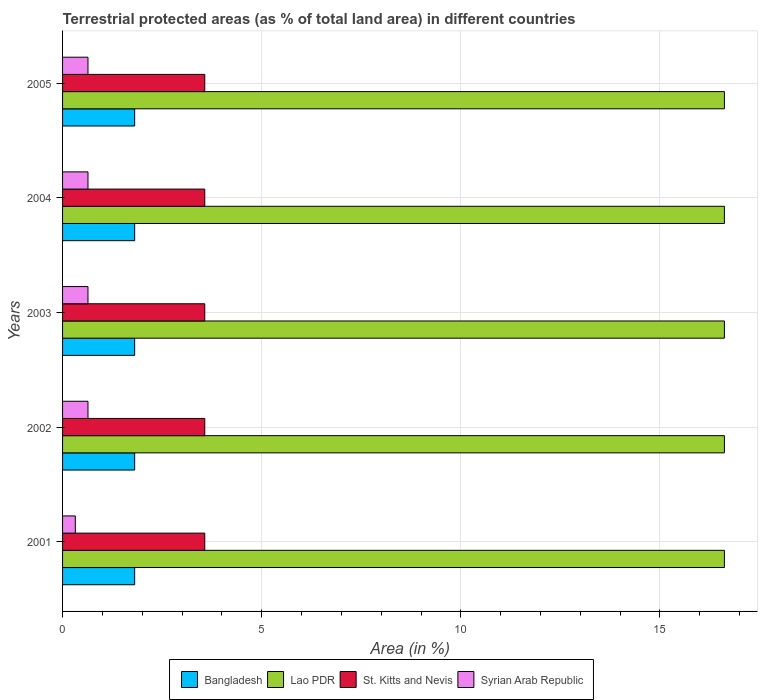How many bars are there on the 1st tick from the top?
Offer a very short reply. 4. How many bars are there on the 5th tick from the bottom?
Ensure brevity in your answer.  4. In how many cases, is the number of bars for a given year not equal to the number of legend labels?
Your answer should be very brief. 0. What is the percentage of terrestrial protected land in Syrian Arab Republic in 2003?
Offer a terse response. 0.64. Across all years, what is the maximum percentage of terrestrial protected land in St. Kitts and Nevis?
Your answer should be compact. 3.57. Across all years, what is the minimum percentage of terrestrial protected land in Syrian Arab Republic?
Keep it short and to the point. 0.32. In which year was the percentage of terrestrial protected land in St. Kitts and Nevis maximum?
Offer a terse response. 2001. In which year was the percentage of terrestrial protected land in Bangladesh minimum?
Your response must be concise. 2001. What is the total percentage of terrestrial protected land in Lao PDR in the graph?
Your answer should be very brief. 83.09. What is the difference between the percentage of terrestrial protected land in Lao PDR in 2004 and the percentage of terrestrial protected land in Syrian Arab Republic in 2001?
Offer a terse response. 16.3. What is the average percentage of terrestrial protected land in Lao PDR per year?
Provide a short and direct response. 16.62. In the year 2004, what is the difference between the percentage of terrestrial protected land in Syrian Arab Republic and percentage of terrestrial protected land in St. Kitts and Nevis?
Keep it short and to the point. -2.93. What is the ratio of the percentage of terrestrial protected land in Lao PDR in 2003 to that in 2005?
Your response must be concise. 1. Is the difference between the percentage of terrestrial protected land in Syrian Arab Republic in 2001 and 2003 greater than the difference between the percentage of terrestrial protected land in St. Kitts and Nevis in 2001 and 2003?
Your answer should be very brief. No. In how many years, is the percentage of terrestrial protected land in Syrian Arab Republic greater than the average percentage of terrestrial protected land in Syrian Arab Republic taken over all years?
Keep it short and to the point. 4. Is the sum of the percentage of terrestrial protected land in Lao PDR in 2001 and 2003 greater than the maximum percentage of terrestrial protected land in Bangladesh across all years?
Provide a succinct answer. Yes. Is it the case that in every year, the sum of the percentage of terrestrial protected land in Bangladesh and percentage of terrestrial protected land in St. Kitts and Nevis is greater than the sum of percentage of terrestrial protected land in Lao PDR and percentage of terrestrial protected land in Syrian Arab Republic?
Provide a succinct answer. No. What does the 2nd bar from the top in 2002 represents?
Give a very brief answer. St. Kitts and Nevis. What does the 3rd bar from the bottom in 2003 represents?
Your answer should be very brief. St. Kitts and Nevis. Is it the case that in every year, the sum of the percentage of terrestrial protected land in Syrian Arab Republic and percentage of terrestrial protected land in Bangladesh is greater than the percentage of terrestrial protected land in St. Kitts and Nevis?
Your response must be concise. No. Are the values on the major ticks of X-axis written in scientific E-notation?
Provide a succinct answer. No. Does the graph contain grids?
Your answer should be very brief. Yes. Where does the legend appear in the graph?
Provide a succinct answer. Bottom center. How many legend labels are there?
Your response must be concise. 4. How are the legend labels stacked?
Provide a short and direct response. Horizontal. What is the title of the graph?
Your answer should be very brief. Terrestrial protected areas (as % of total land area) in different countries. Does "East Asia (all income levels)" appear as one of the legend labels in the graph?
Keep it short and to the point. No. What is the label or title of the X-axis?
Ensure brevity in your answer.  Area (in %). What is the Area (in %) of Bangladesh in 2001?
Provide a succinct answer. 1.81. What is the Area (in %) of Lao PDR in 2001?
Your response must be concise. 16.62. What is the Area (in %) in St. Kitts and Nevis in 2001?
Keep it short and to the point. 3.57. What is the Area (in %) in Syrian Arab Republic in 2001?
Offer a very short reply. 0.32. What is the Area (in %) of Bangladesh in 2002?
Your answer should be compact. 1.81. What is the Area (in %) of Lao PDR in 2002?
Offer a terse response. 16.62. What is the Area (in %) in St. Kitts and Nevis in 2002?
Your answer should be very brief. 3.57. What is the Area (in %) in Syrian Arab Republic in 2002?
Give a very brief answer. 0.64. What is the Area (in %) of Bangladesh in 2003?
Give a very brief answer. 1.81. What is the Area (in %) in Lao PDR in 2003?
Give a very brief answer. 16.62. What is the Area (in %) of St. Kitts and Nevis in 2003?
Your answer should be very brief. 3.57. What is the Area (in %) in Syrian Arab Republic in 2003?
Make the answer very short. 0.64. What is the Area (in %) in Bangladesh in 2004?
Provide a succinct answer. 1.81. What is the Area (in %) of Lao PDR in 2004?
Provide a succinct answer. 16.62. What is the Area (in %) of St. Kitts and Nevis in 2004?
Provide a succinct answer. 3.57. What is the Area (in %) in Syrian Arab Republic in 2004?
Your answer should be compact. 0.64. What is the Area (in %) in Bangladesh in 2005?
Give a very brief answer. 1.81. What is the Area (in %) in Lao PDR in 2005?
Your response must be concise. 16.62. What is the Area (in %) in St. Kitts and Nevis in 2005?
Provide a succinct answer. 3.57. What is the Area (in %) of Syrian Arab Republic in 2005?
Offer a terse response. 0.64. Across all years, what is the maximum Area (in %) of Bangladesh?
Your answer should be very brief. 1.81. Across all years, what is the maximum Area (in %) in Lao PDR?
Provide a short and direct response. 16.62. Across all years, what is the maximum Area (in %) in St. Kitts and Nevis?
Provide a short and direct response. 3.57. Across all years, what is the maximum Area (in %) of Syrian Arab Republic?
Your answer should be compact. 0.64. Across all years, what is the minimum Area (in %) of Bangladesh?
Keep it short and to the point. 1.81. Across all years, what is the minimum Area (in %) of Lao PDR?
Offer a terse response. 16.62. Across all years, what is the minimum Area (in %) of St. Kitts and Nevis?
Provide a short and direct response. 3.57. Across all years, what is the minimum Area (in %) of Syrian Arab Republic?
Give a very brief answer. 0.32. What is the total Area (in %) of Bangladesh in the graph?
Make the answer very short. 9.05. What is the total Area (in %) of Lao PDR in the graph?
Your response must be concise. 83.09. What is the total Area (in %) of St. Kitts and Nevis in the graph?
Make the answer very short. 17.85. What is the total Area (in %) in Syrian Arab Republic in the graph?
Offer a terse response. 2.87. What is the difference between the Area (in %) in Bangladesh in 2001 and that in 2002?
Give a very brief answer. 0. What is the difference between the Area (in %) of Lao PDR in 2001 and that in 2002?
Your answer should be compact. 0. What is the difference between the Area (in %) in Syrian Arab Republic in 2001 and that in 2002?
Make the answer very short. -0.32. What is the difference between the Area (in %) of Lao PDR in 2001 and that in 2003?
Provide a succinct answer. 0. What is the difference between the Area (in %) in St. Kitts and Nevis in 2001 and that in 2003?
Your response must be concise. 0. What is the difference between the Area (in %) in Syrian Arab Republic in 2001 and that in 2003?
Provide a short and direct response. -0.32. What is the difference between the Area (in %) in Lao PDR in 2001 and that in 2004?
Give a very brief answer. 0. What is the difference between the Area (in %) of St. Kitts and Nevis in 2001 and that in 2004?
Ensure brevity in your answer.  0. What is the difference between the Area (in %) of Syrian Arab Republic in 2001 and that in 2004?
Provide a short and direct response. -0.32. What is the difference between the Area (in %) of Lao PDR in 2001 and that in 2005?
Offer a terse response. 0. What is the difference between the Area (in %) in St. Kitts and Nevis in 2001 and that in 2005?
Provide a short and direct response. 0. What is the difference between the Area (in %) in Syrian Arab Republic in 2001 and that in 2005?
Your answer should be very brief. -0.32. What is the difference between the Area (in %) of Lao PDR in 2002 and that in 2003?
Keep it short and to the point. 0. What is the difference between the Area (in %) of Syrian Arab Republic in 2002 and that in 2003?
Your answer should be very brief. 0. What is the difference between the Area (in %) of Lao PDR in 2002 and that in 2004?
Offer a terse response. 0. What is the difference between the Area (in %) in St. Kitts and Nevis in 2002 and that in 2004?
Your answer should be very brief. 0. What is the difference between the Area (in %) in Syrian Arab Republic in 2002 and that in 2004?
Give a very brief answer. 0. What is the difference between the Area (in %) of Bangladesh in 2002 and that in 2005?
Make the answer very short. 0. What is the difference between the Area (in %) of St. Kitts and Nevis in 2002 and that in 2005?
Your answer should be compact. 0. What is the difference between the Area (in %) of Bangladesh in 2003 and that in 2004?
Ensure brevity in your answer.  0. What is the difference between the Area (in %) in Lao PDR in 2003 and that in 2004?
Your answer should be compact. 0. What is the difference between the Area (in %) in St. Kitts and Nevis in 2003 and that in 2004?
Your response must be concise. 0. What is the difference between the Area (in %) of St. Kitts and Nevis in 2003 and that in 2005?
Your answer should be compact. 0. What is the difference between the Area (in %) in St. Kitts and Nevis in 2004 and that in 2005?
Ensure brevity in your answer.  0. What is the difference between the Area (in %) in Syrian Arab Republic in 2004 and that in 2005?
Provide a short and direct response. 0. What is the difference between the Area (in %) in Bangladesh in 2001 and the Area (in %) in Lao PDR in 2002?
Make the answer very short. -14.81. What is the difference between the Area (in %) of Bangladesh in 2001 and the Area (in %) of St. Kitts and Nevis in 2002?
Keep it short and to the point. -1.76. What is the difference between the Area (in %) of Bangladesh in 2001 and the Area (in %) of Syrian Arab Republic in 2002?
Provide a succinct answer. 1.17. What is the difference between the Area (in %) in Lao PDR in 2001 and the Area (in %) in St. Kitts and Nevis in 2002?
Ensure brevity in your answer.  13.05. What is the difference between the Area (in %) of Lao PDR in 2001 and the Area (in %) of Syrian Arab Republic in 2002?
Your answer should be compact. 15.98. What is the difference between the Area (in %) of St. Kitts and Nevis in 2001 and the Area (in %) of Syrian Arab Republic in 2002?
Give a very brief answer. 2.93. What is the difference between the Area (in %) of Bangladesh in 2001 and the Area (in %) of Lao PDR in 2003?
Ensure brevity in your answer.  -14.81. What is the difference between the Area (in %) of Bangladesh in 2001 and the Area (in %) of St. Kitts and Nevis in 2003?
Provide a succinct answer. -1.76. What is the difference between the Area (in %) of Bangladesh in 2001 and the Area (in %) of Syrian Arab Republic in 2003?
Provide a succinct answer. 1.17. What is the difference between the Area (in %) in Lao PDR in 2001 and the Area (in %) in St. Kitts and Nevis in 2003?
Give a very brief answer. 13.05. What is the difference between the Area (in %) in Lao PDR in 2001 and the Area (in %) in Syrian Arab Republic in 2003?
Your answer should be very brief. 15.98. What is the difference between the Area (in %) in St. Kitts and Nevis in 2001 and the Area (in %) in Syrian Arab Republic in 2003?
Make the answer very short. 2.93. What is the difference between the Area (in %) in Bangladesh in 2001 and the Area (in %) in Lao PDR in 2004?
Provide a succinct answer. -14.81. What is the difference between the Area (in %) of Bangladesh in 2001 and the Area (in %) of St. Kitts and Nevis in 2004?
Give a very brief answer. -1.76. What is the difference between the Area (in %) of Bangladesh in 2001 and the Area (in %) of Syrian Arab Republic in 2004?
Keep it short and to the point. 1.17. What is the difference between the Area (in %) in Lao PDR in 2001 and the Area (in %) in St. Kitts and Nevis in 2004?
Offer a terse response. 13.05. What is the difference between the Area (in %) of Lao PDR in 2001 and the Area (in %) of Syrian Arab Republic in 2004?
Provide a succinct answer. 15.98. What is the difference between the Area (in %) of St. Kitts and Nevis in 2001 and the Area (in %) of Syrian Arab Republic in 2004?
Offer a very short reply. 2.93. What is the difference between the Area (in %) of Bangladesh in 2001 and the Area (in %) of Lao PDR in 2005?
Provide a succinct answer. -14.81. What is the difference between the Area (in %) of Bangladesh in 2001 and the Area (in %) of St. Kitts and Nevis in 2005?
Your response must be concise. -1.76. What is the difference between the Area (in %) in Bangladesh in 2001 and the Area (in %) in Syrian Arab Republic in 2005?
Ensure brevity in your answer.  1.17. What is the difference between the Area (in %) in Lao PDR in 2001 and the Area (in %) in St. Kitts and Nevis in 2005?
Your answer should be compact. 13.05. What is the difference between the Area (in %) of Lao PDR in 2001 and the Area (in %) of Syrian Arab Republic in 2005?
Provide a succinct answer. 15.98. What is the difference between the Area (in %) of St. Kitts and Nevis in 2001 and the Area (in %) of Syrian Arab Republic in 2005?
Make the answer very short. 2.93. What is the difference between the Area (in %) in Bangladesh in 2002 and the Area (in %) in Lao PDR in 2003?
Provide a short and direct response. -14.81. What is the difference between the Area (in %) in Bangladesh in 2002 and the Area (in %) in St. Kitts and Nevis in 2003?
Offer a terse response. -1.76. What is the difference between the Area (in %) of Bangladesh in 2002 and the Area (in %) of Syrian Arab Republic in 2003?
Provide a short and direct response. 1.17. What is the difference between the Area (in %) of Lao PDR in 2002 and the Area (in %) of St. Kitts and Nevis in 2003?
Provide a succinct answer. 13.05. What is the difference between the Area (in %) in Lao PDR in 2002 and the Area (in %) in Syrian Arab Republic in 2003?
Ensure brevity in your answer.  15.98. What is the difference between the Area (in %) of St. Kitts and Nevis in 2002 and the Area (in %) of Syrian Arab Republic in 2003?
Your answer should be compact. 2.93. What is the difference between the Area (in %) in Bangladesh in 2002 and the Area (in %) in Lao PDR in 2004?
Ensure brevity in your answer.  -14.81. What is the difference between the Area (in %) in Bangladesh in 2002 and the Area (in %) in St. Kitts and Nevis in 2004?
Provide a short and direct response. -1.76. What is the difference between the Area (in %) of Bangladesh in 2002 and the Area (in %) of Syrian Arab Republic in 2004?
Provide a succinct answer. 1.17. What is the difference between the Area (in %) in Lao PDR in 2002 and the Area (in %) in St. Kitts and Nevis in 2004?
Your answer should be compact. 13.05. What is the difference between the Area (in %) in Lao PDR in 2002 and the Area (in %) in Syrian Arab Republic in 2004?
Offer a very short reply. 15.98. What is the difference between the Area (in %) in St. Kitts and Nevis in 2002 and the Area (in %) in Syrian Arab Republic in 2004?
Make the answer very short. 2.93. What is the difference between the Area (in %) of Bangladesh in 2002 and the Area (in %) of Lao PDR in 2005?
Your answer should be very brief. -14.81. What is the difference between the Area (in %) in Bangladesh in 2002 and the Area (in %) in St. Kitts and Nevis in 2005?
Your answer should be very brief. -1.76. What is the difference between the Area (in %) of Bangladesh in 2002 and the Area (in %) of Syrian Arab Republic in 2005?
Give a very brief answer. 1.17. What is the difference between the Area (in %) of Lao PDR in 2002 and the Area (in %) of St. Kitts and Nevis in 2005?
Make the answer very short. 13.05. What is the difference between the Area (in %) of Lao PDR in 2002 and the Area (in %) of Syrian Arab Republic in 2005?
Offer a very short reply. 15.98. What is the difference between the Area (in %) in St. Kitts and Nevis in 2002 and the Area (in %) in Syrian Arab Republic in 2005?
Your response must be concise. 2.93. What is the difference between the Area (in %) in Bangladesh in 2003 and the Area (in %) in Lao PDR in 2004?
Keep it short and to the point. -14.81. What is the difference between the Area (in %) of Bangladesh in 2003 and the Area (in %) of St. Kitts and Nevis in 2004?
Ensure brevity in your answer.  -1.76. What is the difference between the Area (in %) of Bangladesh in 2003 and the Area (in %) of Syrian Arab Republic in 2004?
Your response must be concise. 1.17. What is the difference between the Area (in %) of Lao PDR in 2003 and the Area (in %) of St. Kitts and Nevis in 2004?
Your answer should be compact. 13.05. What is the difference between the Area (in %) of Lao PDR in 2003 and the Area (in %) of Syrian Arab Republic in 2004?
Your answer should be compact. 15.98. What is the difference between the Area (in %) in St. Kitts and Nevis in 2003 and the Area (in %) in Syrian Arab Republic in 2004?
Give a very brief answer. 2.93. What is the difference between the Area (in %) of Bangladesh in 2003 and the Area (in %) of Lao PDR in 2005?
Your answer should be very brief. -14.81. What is the difference between the Area (in %) of Bangladesh in 2003 and the Area (in %) of St. Kitts and Nevis in 2005?
Make the answer very short. -1.76. What is the difference between the Area (in %) in Bangladesh in 2003 and the Area (in %) in Syrian Arab Republic in 2005?
Your response must be concise. 1.17. What is the difference between the Area (in %) in Lao PDR in 2003 and the Area (in %) in St. Kitts and Nevis in 2005?
Provide a succinct answer. 13.05. What is the difference between the Area (in %) of Lao PDR in 2003 and the Area (in %) of Syrian Arab Republic in 2005?
Ensure brevity in your answer.  15.98. What is the difference between the Area (in %) in St. Kitts and Nevis in 2003 and the Area (in %) in Syrian Arab Republic in 2005?
Keep it short and to the point. 2.93. What is the difference between the Area (in %) of Bangladesh in 2004 and the Area (in %) of Lao PDR in 2005?
Your answer should be very brief. -14.81. What is the difference between the Area (in %) of Bangladesh in 2004 and the Area (in %) of St. Kitts and Nevis in 2005?
Make the answer very short. -1.76. What is the difference between the Area (in %) of Bangladesh in 2004 and the Area (in %) of Syrian Arab Republic in 2005?
Provide a short and direct response. 1.17. What is the difference between the Area (in %) in Lao PDR in 2004 and the Area (in %) in St. Kitts and Nevis in 2005?
Your answer should be compact. 13.05. What is the difference between the Area (in %) in Lao PDR in 2004 and the Area (in %) in Syrian Arab Republic in 2005?
Provide a short and direct response. 15.98. What is the difference between the Area (in %) in St. Kitts and Nevis in 2004 and the Area (in %) in Syrian Arab Republic in 2005?
Offer a terse response. 2.93. What is the average Area (in %) in Bangladesh per year?
Keep it short and to the point. 1.81. What is the average Area (in %) in Lao PDR per year?
Provide a short and direct response. 16.62. What is the average Area (in %) in St. Kitts and Nevis per year?
Your answer should be very brief. 3.57. What is the average Area (in %) in Syrian Arab Republic per year?
Your response must be concise. 0.57. In the year 2001, what is the difference between the Area (in %) in Bangladesh and Area (in %) in Lao PDR?
Ensure brevity in your answer.  -14.81. In the year 2001, what is the difference between the Area (in %) in Bangladesh and Area (in %) in St. Kitts and Nevis?
Your response must be concise. -1.76. In the year 2001, what is the difference between the Area (in %) of Bangladesh and Area (in %) of Syrian Arab Republic?
Your answer should be very brief. 1.49. In the year 2001, what is the difference between the Area (in %) of Lao PDR and Area (in %) of St. Kitts and Nevis?
Make the answer very short. 13.05. In the year 2001, what is the difference between the Area (in %) of Lao PDR and Area (in %) of Syrian Arab Republic?
Provide a succinct answer. 16.3. In the year 2001, what is the difference between the Area (in %) in St. Kitts and Nevis and Area (in %) in Syrian Arab Republic?
Your answer should be compact. 3.25. In the year 2002, what is the difference between the Area (in %) of Bangladesh and Area (in %) of Lao PDR?
Provide a short and direct response. -14.81. In the year 2002, what is the difference between the Area (in %) of Bangladesh and Area (in %) of St. Kitts and Nevis?
Your response must be concise. -1.76. In the year 2002, what is the difference between the Area (in %) in Bangladesh and Area (in %) in Syrian Arab Republic?
Ensure brevity in your answer.  1.17. In the year 2002, what is the difference between the Area (in %) of Lao PDR and Area (in %) of St. Kitts and Nevis?
Your response must be concise. 13.05. In the year 2002, what is the difference between the Area (in %) of Lao PDR and Area (in %) of Syrian Arab Republic?
Make the answer very short. 15.98. In the year 2002, what is the difference between the Area (in %) in St. Kitts and Nevis and Area (in %) in Syrian Arab Republic?
Give a very brief answer. 2.93. In the year 2003, what is the difference between the Area (in %) in Bangladesh and Area (in %) in Lao PDR?
Make the answer very short. -14.81. In the year 2003, what is the difference between the Area (in %) in Bangladesh and Area (in %) in St. Kitts and Nevis?
Make the answer very short. -1.76. In the year 2003, what is the difference between the Area (in %) in Bangladesh and Area (in %) in Syrian Arab Republic?
Your answer should be very brief. 1.17. In the year 2003, what is the difference between the Area (in %) of Lao PDR and Area (in %) of St. Kitts and Nevis?
Provide a short and direct response. 13.05. In the year 2003, what is the difference between the Area (in %) in Lao PDR and Area (in %) in Syrian Arab Republic?
Ensure brevity in your answer.  15.98. In the year 2003, what is the difference between the Area (in %) in St. Kitts and Nevis and Area (in %) in Syrian Arab Republic?
Your response must be concise. 2.93. In the year 2004, what is the difference between the Area (in %) of Bangladesh and Area (in %) of Lao PDR?
Provide a succinct answer. -14.81. In the year 2004, what is the difference between the Area (in %) of Bangladesh and Area (in %) of St. Kitts and Nevis?
Offer a terse response. -1.76. In the year 2004, what is the difference between the Area (in %) of Bangladesh and Area (in %) of Syrian Arab Republic?
Your answer should be compact. 1.17. In the year 2004, what is the difference between the Area (in %) of Lao PDR and Area (in %) of St. Kitts and Nevis?
Provide a succinct answer. 13.05. In the year 2004, what is the difference between the Area (in %) of Lao PDR and Area (in %) of Syrian Arab Republic?
Provide a short and direct response. 15.98. In the year 2004, what is the difference between the Area (in %) of St. Kitts and Nevis and Area (in %) of Syrian Arab Republic?
Ensure brevity in your answer.  2.93. In the year 2005, what is the difference between the Area (in %) of Bangladesh and Area (in %) of Lao PDR?
Provide a succinct answer. -14.81. In the year 2005, what is the difference between the Area (in %) of Bangladesh and Area (in %) of St. Kitts and Nevis?
Provide a succinct answer. -1.76. In the year 2005, what is the difference between the Area (in %) of Bangladesh and Area (in %) of Syrian Arab Republic?
Provide a succinct answer. 1.17. In the year 2005, what is the difference between the Area (in %) in Lao PDR and Area (in %) in St. Kitts and Nevis?
Offer a very short reply. 13.05. In the year 2005, what is the difference between the Area (in %) in Lao PDR and Area (in %) in Syrian Arab Republic?
Provide a short and direct response. 15.98. In the year 2005, what is the difference between the Area (in %) in St. Kitts and Nevis and Area (in %) in Syrian Arab Republic?
Your response must be concise. 2.93. What is the ratio of the Area (in %) in Lao PDR in 2001 to that in 2002?
Your answer should be very brief. 1. What is the ratio of the Area (in %) of St. Kitts and Nevis in 2001 to that in 2002?
Offer a terse response. 1. What is the ratio of the Area (in %) of Syrian Arab Republic in 2001 to that in 2002?
Provide a succinct answer. 0.5. What is the ratio of the Area (in %) of Lao PDR in 2001 to that in 2003?
Give a very brief answer. 1. What is the ratio of the Area (in %) in St. Kitts and Nevis in 2001 to that in 2003?
Your response must be concise. 1. What is the ratio of the Area (in %) of Syrian Arab Republic in 2001 to that in 2003?
Ensure brevity in your answer.  0.5. What is the ratio of the Area (in %) in Syrian Arab Republic in 2001 to that in 2004?
Your response must be concise. 0.5. What is the ratio of the Area (in %) in Bangladesh in 2001 to that in 2005?
Offer a very short reply. 1. What is the ratio of the Area (in %) in Lao PDR in 2001 to that in 2005?
Offer a very short reply. 1. What is the ratio of the Area (in %) of Syrian Arab Republic in 2001 to that in 2005?
Ensure brevity in your answer.  0.5. What is the ratio of the Area (in %) of Syrian Arab Republic in 2002 to that in 2003?
Provide a short and direct response. 1. What is the ratio of the Area (in %) in Bangladesh in 2002 to that in 2004?
Your answer should be compact. 1. What is the ratio of the Area (in %) in St. Kitts and Nevis in 2002 to that in 2004?
Keep it short and to the point. 1. What is the ratio of the Area (in %) of Syrian Arab Republic in 2002 to that in 2004?
Your answer should be compact. 1. What is the ratio of the Area (in %) in Bangladesh in 2002 to that in 2005?
Offer a terse response. 1. What is the ratio of the Area (in %) in Lao PDR in 2002 to that in 2005?
Keep it short and to the point. 1. What is the ratio of the Area (in %) in St. Kitts and Nevis in 2002 to that in 2005?
Make the answer very short. 1. What is the ratio of the Area (in %) of Bangladesh in 2003 to that in 2004?
Ensure brevity in your answer.  1. What is the ratio of the Area (in %) in Bangladesh in 2003 to that in 2005?
Your answer should be very brief. 1. What is the ratio of the Area (in %) in St. Kitts and Nevis in 2003 to that in 2005?
Keep it short and to the point. 1. What is the ratio of the Area (in %) in Syrian Arab Republic in 2003 to that in 2005?
Make the answer very short. 1. What is the ratio of the Area (in %) of Lao PDR in 2004 to that in 2005?
Offer a very short reply. 1. What is the ratio of the Area (in %) of St. Kitts and Nevis in 2004 to that in 2005?
Offer a very short reply. 1. What is the ratio of the Area (in %) of Syrian Arab Republic in 2004 to that in 2005?
Provide a succinct answer. 1. What is the difference between the highest and the second highest Area (in %) of Bangladesh?
Provide a succinct answer. 0. What is the difference between the highest and the second highest Area (in %) of St. Kitts and Nevis?
Keep it short and to the point. 0. What is the difference between the highest and the lowest Area (in %) in Bangladesh?
Make the answer very short. 0. What is the difference between the highest and the lowest Area (in %) in St. Kitts and Nevis?
Keep it short and to the point. 0. What is the difference between the highest and the lowest Area (in %) of Syrian Arab Republic?
Your answer should be very brief. 0.32. 